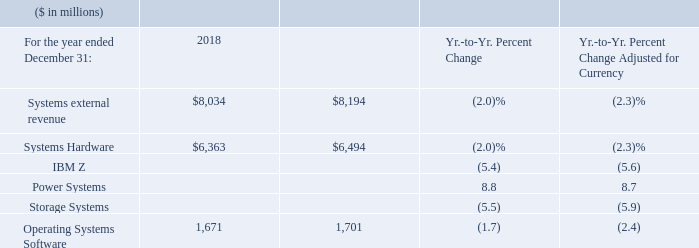Systems revenue of $8,034 million decreased 2.0 percent year to year as reported (2 percent adjusted for currency) driven by strong IBM Z performance in 2017 and continued price pressures impacting Storage Systems in a competitive environment.
Both hardware platforms were down year to year for the full year, as reported and adjusted for currency. This performance was partially offset by strong growth in Power Systems (which grew as reported and adjusted for currency in 2018) with strong performance in POWER9-based systems and Linux throughout the year. Within Systems, cloud revenue of $3.1 billion decreased 10 percent as reported and adjusted for currency compared to the prior year reflecting IBM Z product cycle dynamics.
What led to fall in systems revenue from 2017 to 2018? Strong ibm z performance in 2017 and continued price pressures impacting storage systems in a competitive environment. What factors led to growth in Power Systems  Strong performance in power9-based systems and linux throughout the year. How was the performance of hardware platforms year to year Hardware platforms were down year to year for the full year, as reported and adjusted for currency. What is the increase/ (decrease) in Systems external revenue from 2017 to 2018
Answer scale should be: million. 8,034-8,194
Answer: -160. What is the increase/ (decrease) in the value of Systems Hardware from 2017 to 2018
Answer scale should be: million. 6,363-6,494
Answer: -131. What is the increase/ (decrease) in the value of Operating Systems Software from 2017 to 2018
Answer scale should be: million. 1,671-1,701
Answer: -30. 